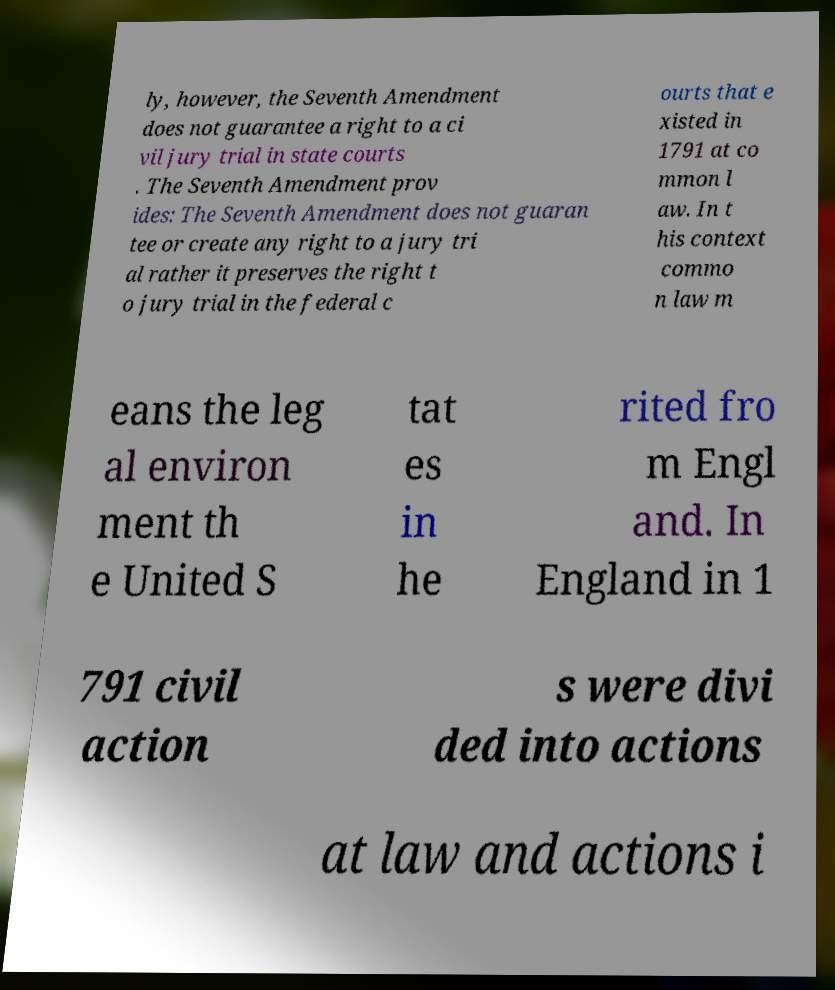There's text embedded in this image that I need extracted. Can you transcribe it verbatim? ly, however, the Seventh Amendment does not guarantee a right to a ci vil jury trial in state courts . The Seventh Amendment prov ides: The Seventh Amendment does not guaran tee or create any right to a jury tri al rather it preserves the right t o jury trial in the federal c ourts that e xisted in 1791 at co mmon l aw. In t his context commo n law m eans the leg al environ ment th e United S tat es in he rited fro m Engl and. In England in 1 791 civil action s were divi ded into actions at law and actions i 